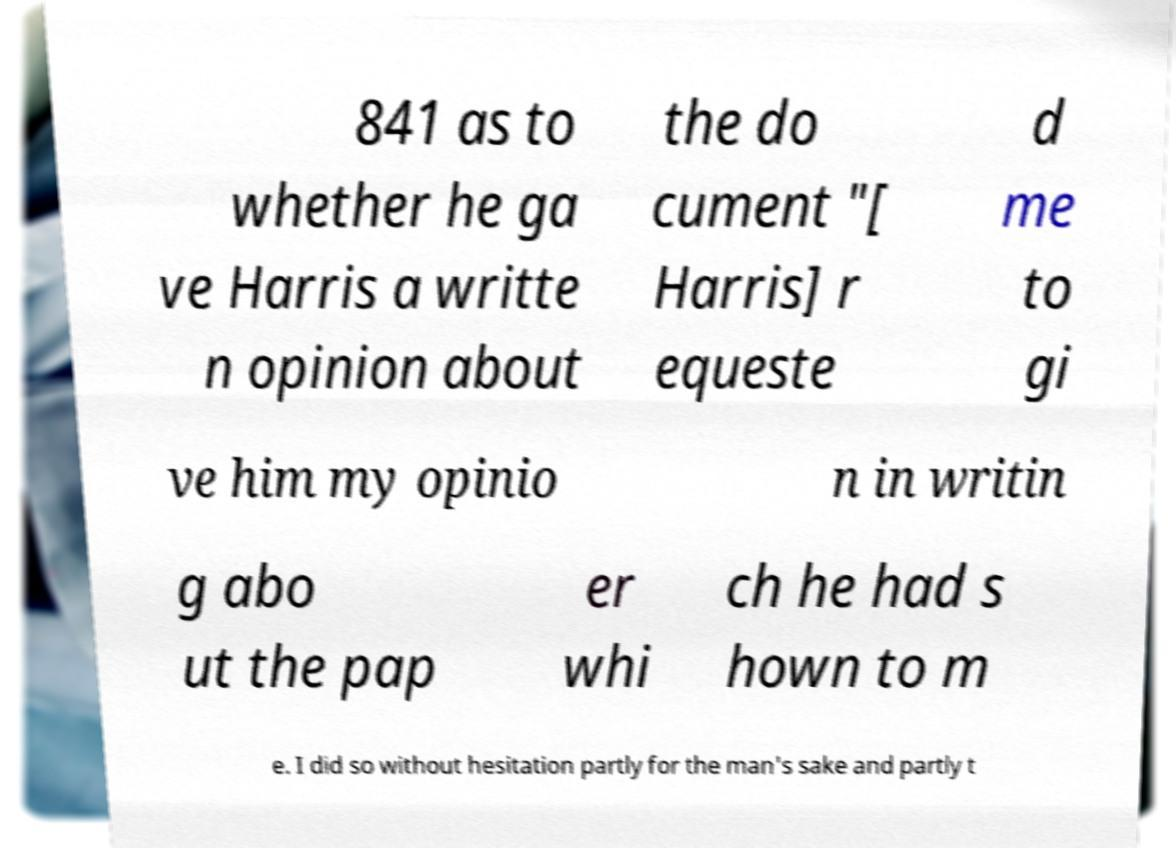Could you assist in decoding the text presented in this image and type it out clearly? 841 as to whether he ga ve Harris a writte n opinion about the do cument "[ Harris] r equeste d me to gi ve him my opinio n in writin g abo ut the pap er whi ch he had s hown to m e. I did so without hesitation partly for the man's sake and partly t 